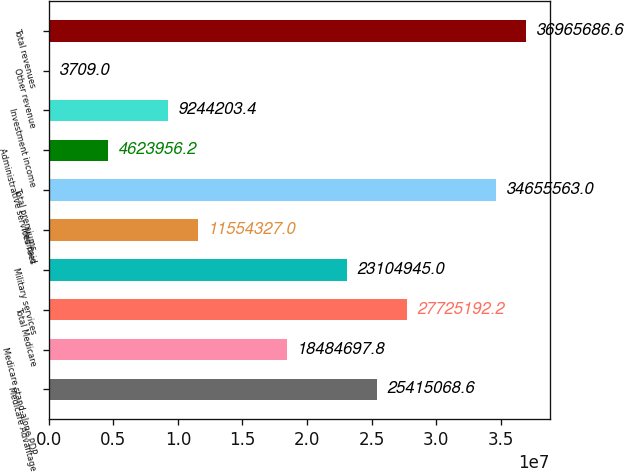Convert chart to OTSL. <chart><loc_0><loc_0><loc_500><loc_500><bar_chart><fcel>Medicare Advantage<fcel>Medicare stand-alone PDP<fcel>Total Medicare<fcel>Military services<fcel>Medicaid<fcel>Total premiums<fcel>Administrative services fees<fcel>Investment income<fcel>Other revenue<fcel>Total revenues<nl><fcel>2.54151e+07<fcel>1.84847e+07<fcel>2.77252e+07<fcel>2.31049e+07<fcel>1.15543e+07<fcel>3.46556e+07<fcel>4.62396e+06<fcel>9.2442e+06<fcel>3709<fcel>3.69657e+07<nl></chart> 